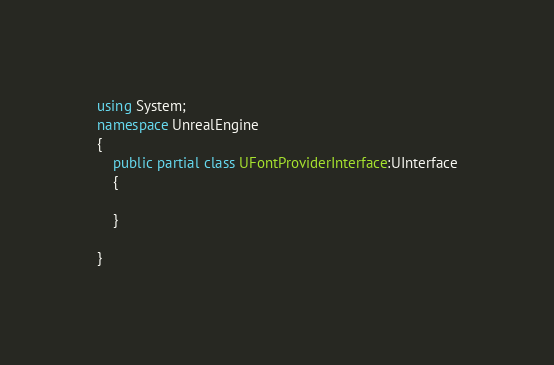Convert code to text. <code><loc_0><loc_0><loc_500><loc_500><_C#_>using System;
namespace UnrealEngine
{
	public partial class UFontProviderInterface:UInterface
	{
		
	}
	
}
</code> 